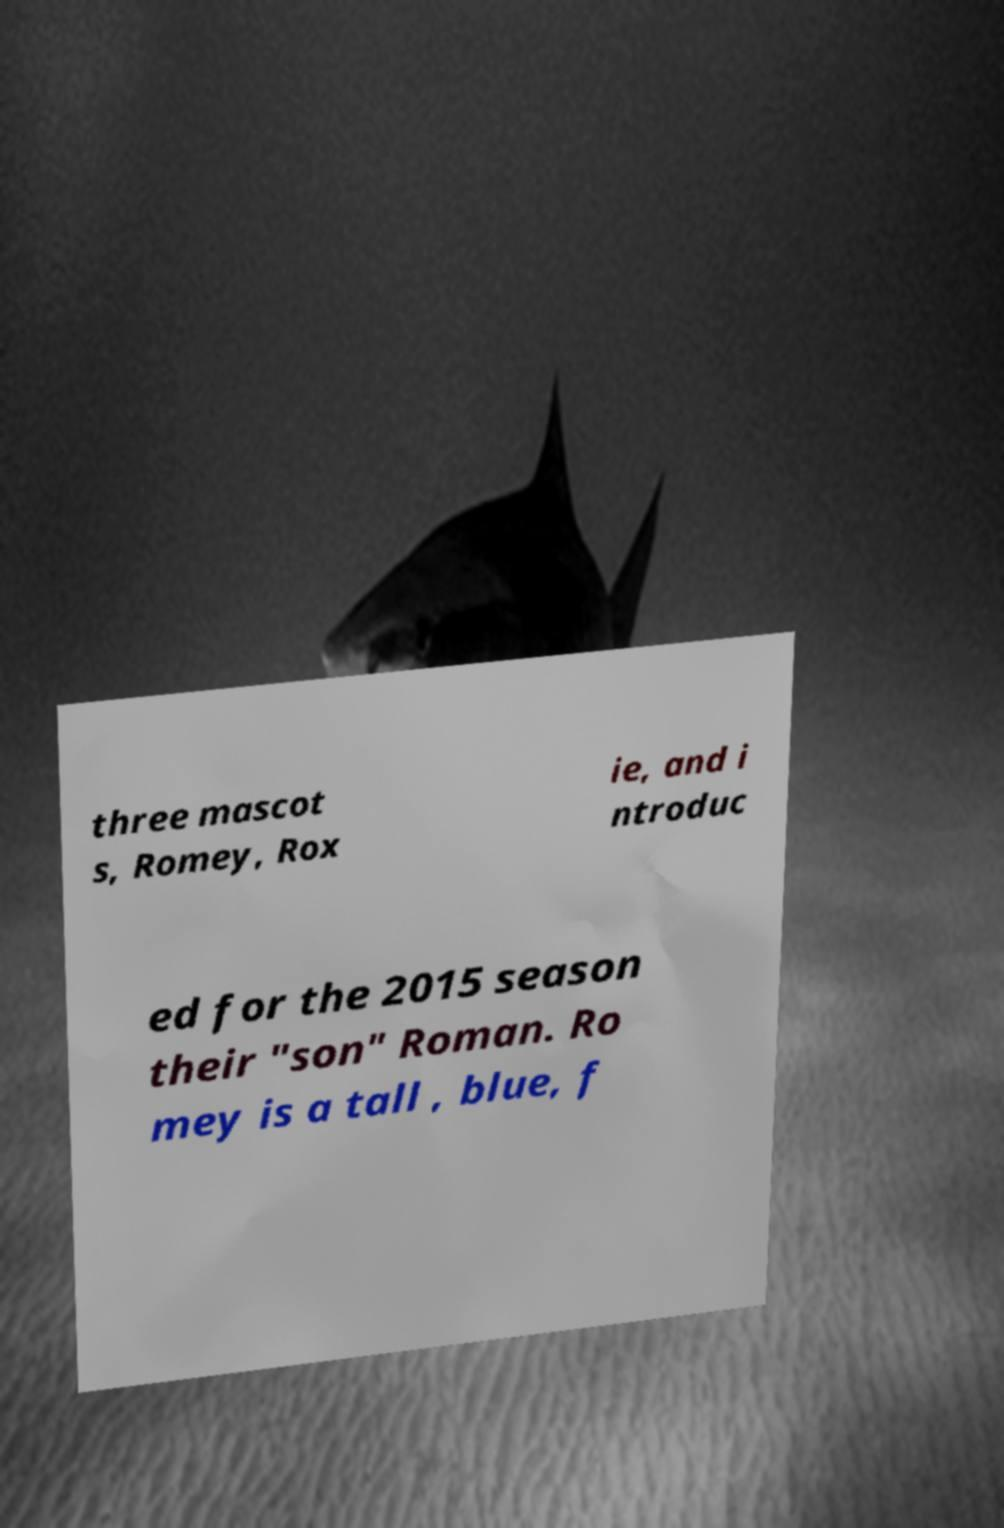What messages or text are displayed in this image? I need them in a readable, typed format. three mascot s, Romey, Rox ie, and i ntroduc ed for the 2015 season their "son" Roman. Ro mey is a tall , blue, f 